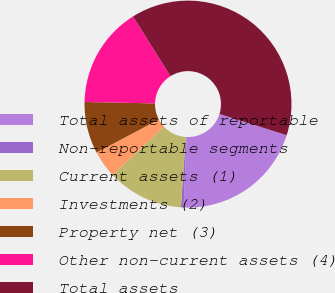Convert chart to OTSL. <chart><loc_0><loc_0><loc_500><loc_500><pie_chart><fcel>Total assets of reportable<fcel>Non-reportable segments<fcel>Current assets (1)<fcel>Investments (2)<fcel>Property net (3)<fcel>Other non-current assets (4)<fcel>Total assets<nl><fcel>20.82%<fcel>0.41%<fcel>11.92%<fcel>4.24%<fcel>8.08%<fcel>15.75%<fcel>38.78%<nl></chart> 